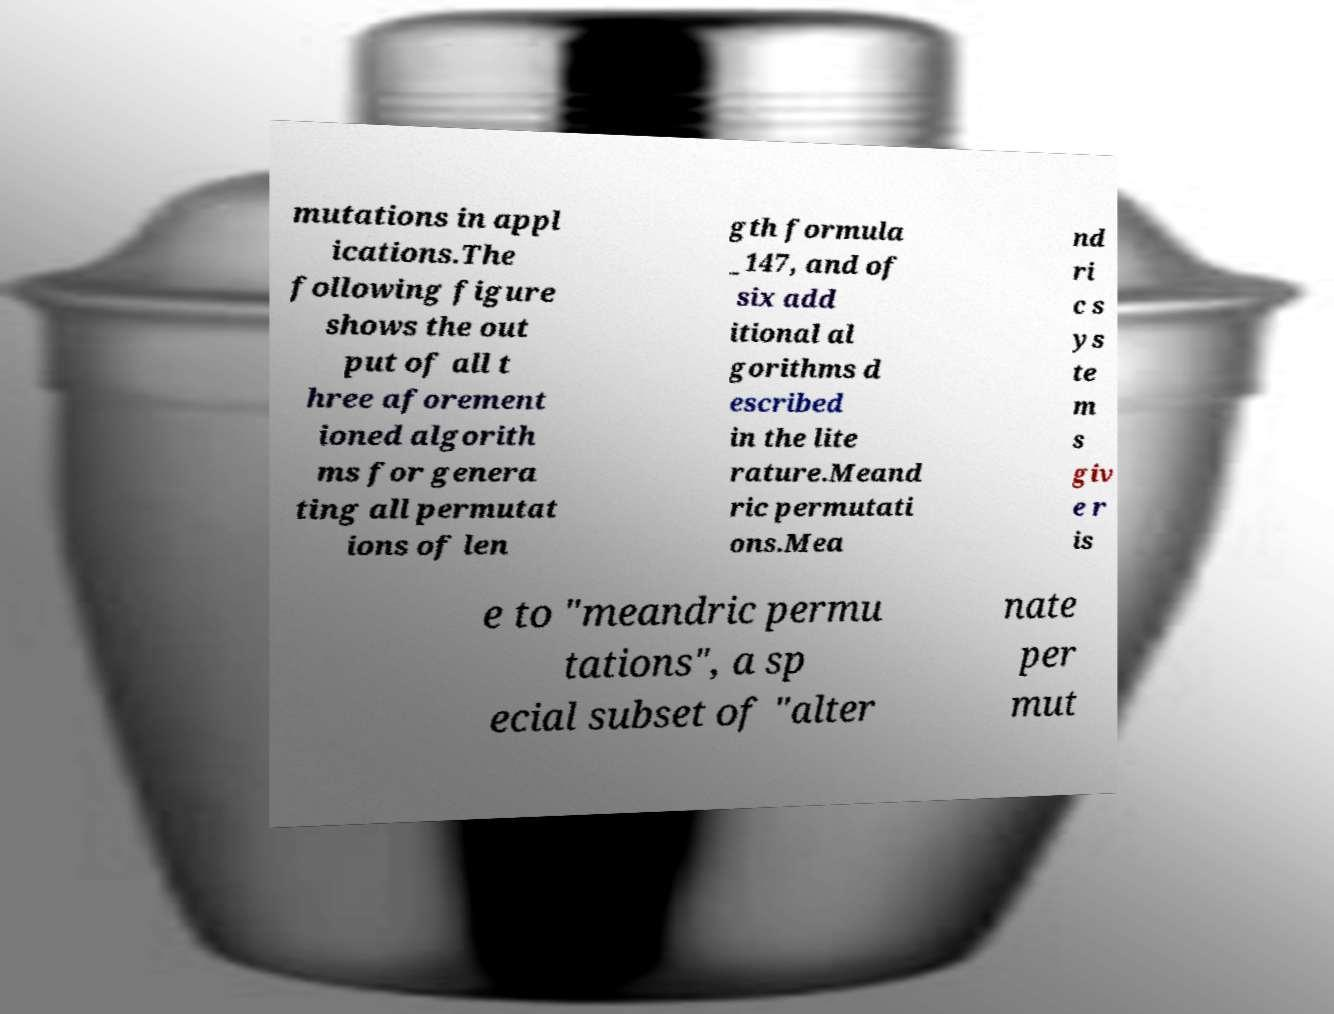What messages or text are displayed in this image? I need them in a readable, typed format. mutations in appl ications.The following figure shows the out put of all t hree aforement ioned algorith ms for genera ting all permutat ions of len gth formula _147, and of six add itional al gorithms d escribed in the lite rature.Meand ric permutati ons.Mea nd ri c s ys te m s giv e r is e to "meandric permu tations", a sp ecial subset of "alter nate per mut 